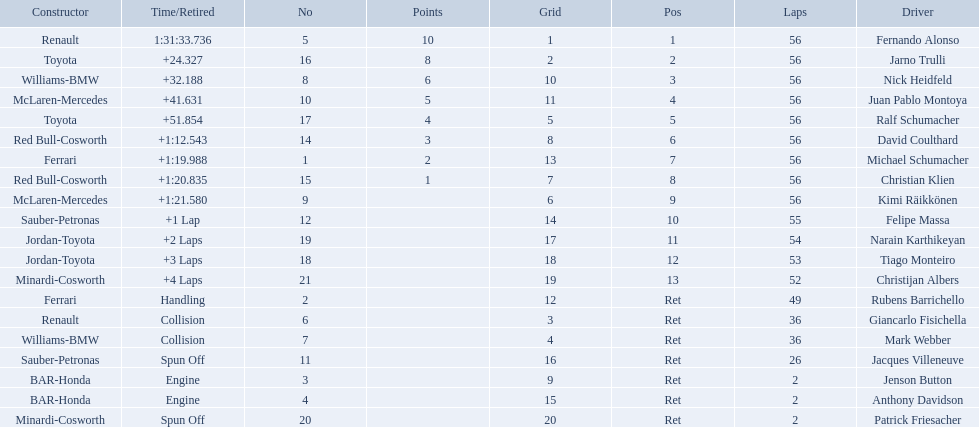What place did fernando alonso finish? 1. How long did it take alonso to finish the race? 1:31:33.736. 